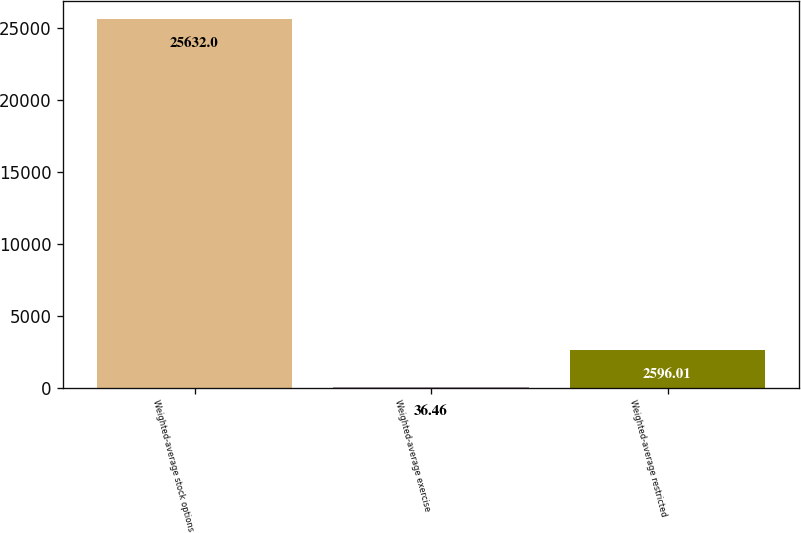Convert chart. <chart><loc_0><loc_0><loc_500><loc_500><bar_chart><fcel>Weighted-average stock options<fcel>Weighted-average exercise<fcel>Weighted-average restricted<nl><fcel>25632<fcel>36.46<fcel>2596.01<nl></chart> 